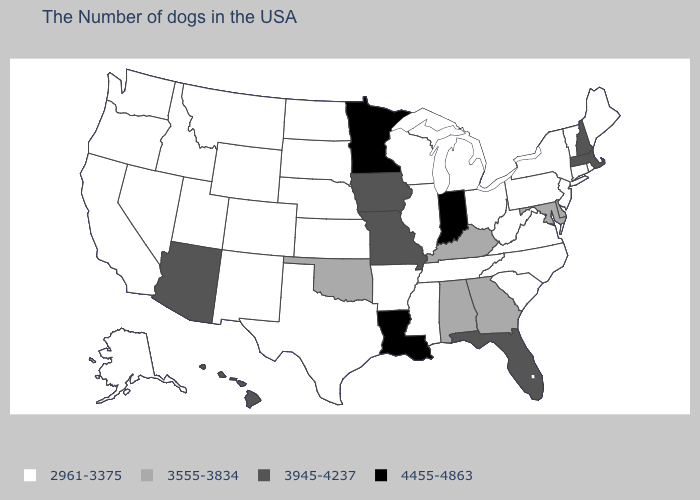Name the states that have a value in the range 4455-4863?
Write a very short answer. Indiana, Louisiana, Minnesota. Which states have the highest value in the USA?
Give a very brief answer. Indiana, Louisiana, Minnesota. Does the first symbol in the legend represent the smallest category?
Concise answer only. Yes. What is the value of Maine?
Be succinct. 2961-3375. What is the value of Nevada?
Keep it brief. 2961-3375. Name the states that have a value in the range 3945-4237?
Be succinct. Massachusetts, New Hampshire, Florida, Missouri, Iowa, Arizona, Hawaii. What is the value of Utah?
Answer briefly. 2961-3375. What is the value of Oklahoma?
Be succinct. 3555-3834. Name the states that have a value in the range 3945-4237?
Give a very brief answer. Massachusetts, New Hampshire, Florida, Missouri, Iowa, Arizona, Hawaii. Does Maine have a higher value than California?
Give a very brief answer. No. Which states have the highest value in the USA?
Be succinct. Indiana, Louisiana, Minnesota. Does Montana have a higher value than Pennsylvania?
Concise answer only. No. Among the states that border Louisiana , which have the highest value?
Quick response, please. Mississippi, Arkansas, Texas. What is the value of Massachusetts?
Short answer required. 3945-4237. Does Indiana have a lower value than Minnesota?
Short answer required. No. 